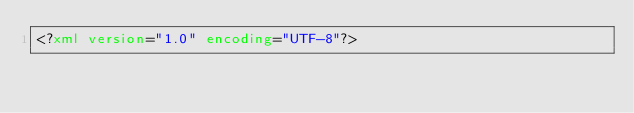<code> <loc_0><loc_0><loc_500><loc_500><_XML_><?xml version="1.0" encoding="UTF-8"?></code> 